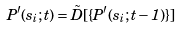<formula> <loc_0><loc_0><loc_500><loc_500>P ^ { \prime } ( s _ { i } ; t ) = \tilde { D } [ \{ P ^ { \prime } ( s _ { i } ; t - 1 ) \} ]</formula> 